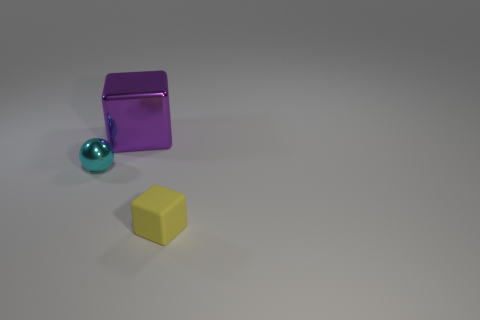The object that is made of the same material as the tiny ball is what size?
Your response must be concise. Large. Is there any other thing that is the same color as the tiny metallic sphere?
Offer a terse response. No. What is the material of the large purple thing that is the same shape as the tiny rubber object?
Provide a succinct answer. Metal. Is the color of the tiny block the same as the metallic cube?
Keep it short and to the point. No. How many objects are either large blue matte spheres or cubes?
Your response must be concise. 2. The matte cube is what size?
Ensure brevity in your answer.  Small. Are there fewer yellow objects than yellow matte cylinders?
Provide a short and direct response. No. What number of balls are the same color as the small rubber block?
Offer a terse response. 0. There is a object to the right of the big purple object; does it have the same color as the large metal cube?
Offer a terse response. No. The thing left of the big cube has what shape?
Provide a succinct answer. Sphere. 